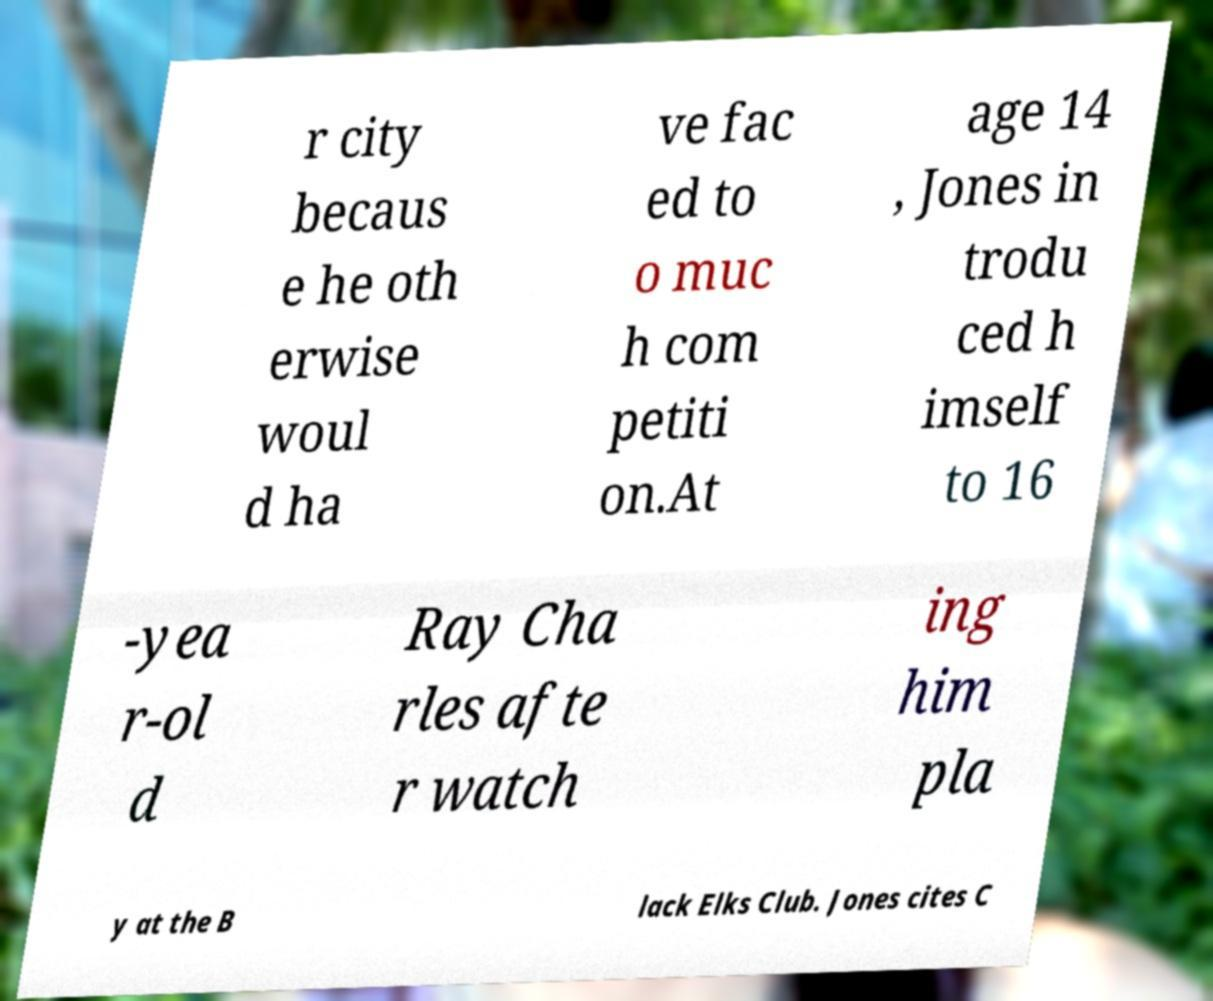Could you extract and type out the text from this image? r city becaus e he oth erwise woul d ha ve fac ed to o muc h com petiti on.At age 14 , Jones in trodu ced h imself to 16 -yea r-ol d Ray Cha rles afte r watch ing him pla y at the B lack Elks Club. Jones cites C 